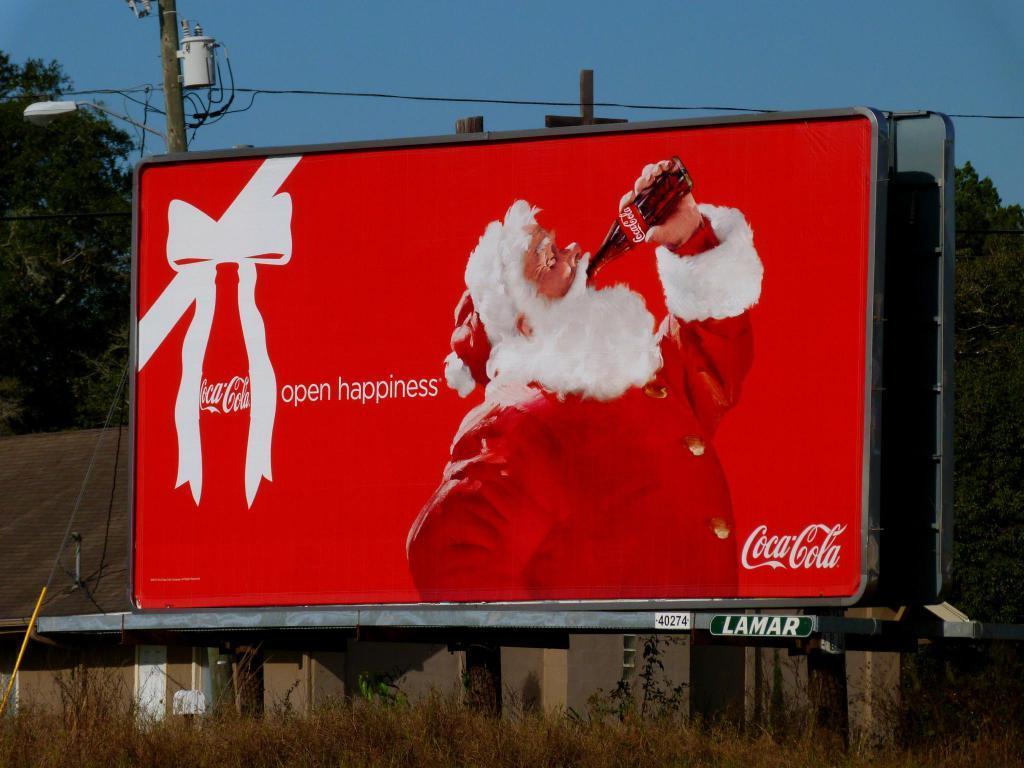In one or two sentences, can you explain what this image depicts? In this image, there is an outside view. There is a hoarding in the middle of the image. There are some trees on the left and on the right side of the image. There is a pole in the top left of the image. There is a sky at the top of the image. 